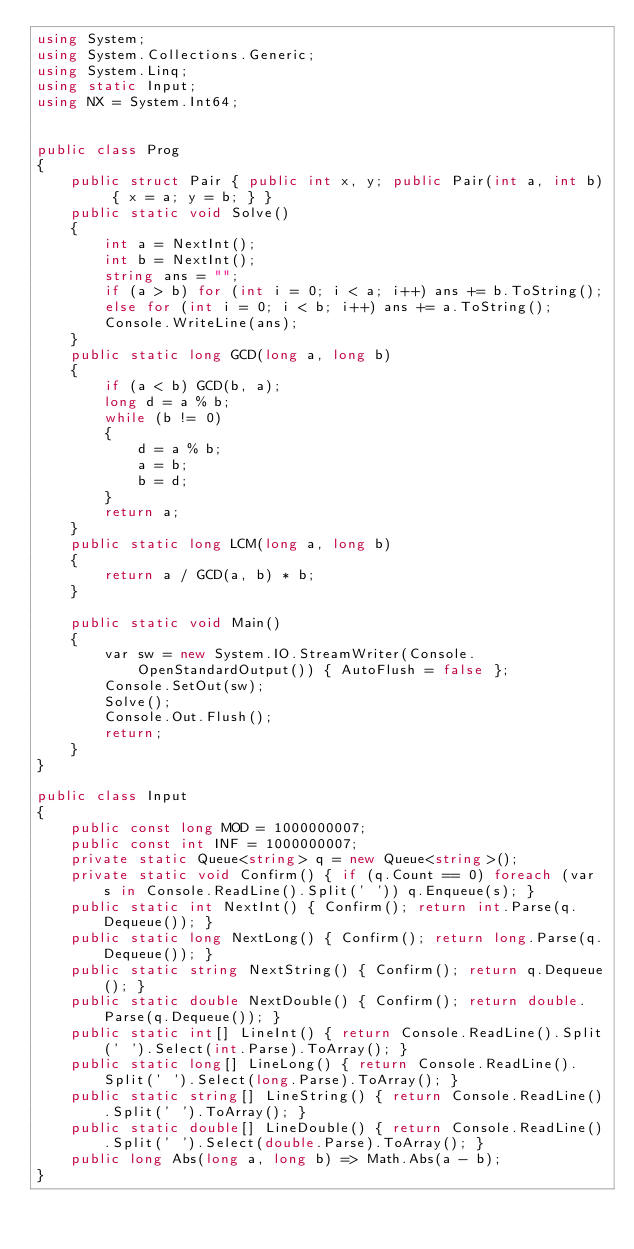Convert code to text. <code><loc_0><loc_0><loc_500><loc_500><_C#_>using System;
using System.Collections.Generic;
using System.Linq;
using static Input;
using NX = System.Int64;


public class Prog
{
    public struct Pair { public int x, y; public Pair(int a, int b) { x = a; y = b; } }
    public static void Solve()
    {
        int a = NextInt();
        int b = NextInt();
        string ans = "";
        if (a > b) for (int i = 0; i < a; i++) ans += b.ToString(); 
        else for (int i = 0; i < b; i++) ans += a.ToString();
        Console.WriteLine(ans);
    }
    public static long GCD(long a, long b)
    {
        if (a < b) GCD(b, a);
        long d = a % b;
        while (b != 0)
        {
            d = a % b;
            a = b;
            b = d;
        }
        return a;
    }
    public static long LCM(long a, long b)
    {
        return a / GCD(a, b) * b;
    }

    public static void Main()
    {
        var sw = new System.IO.StreamWriter(Console.OpenStandardOutput()) { AutoFlush = false };
        Console.SetOut(sw);
        Solve();
        Console.Out.Flush();
        return;
    }
}

public class Input
{
    public const long MOD = 1000000007;
    public const int INF = 1000000007;
    private static Queue<string> q = new Queue<string>();
    private static void Confirm() { if (q.Count == 0) foreach (var s in Console.ReadLine().Split(' ')) q.Enqueue(s); }
    public static int NextInt() { Confirm(); return int.Parse(q.Dequeue()); }
    public static long NextLong() { Confirm(); return long.Parse(q.Dequeue()); }
    public static string NextString() { Confirm(); return q.Dequeue(); }
    public static double NextDouble() { Confirm(); return double.Parse(q.Dequeue()); }
    public static int[] LineInt() { return Console.ReadLine().Split(' ').Select(int.Parse).ToArray(); }
    public static long[] LineLong() { return Console.ReadLine().Split(' ').Select(long.Parse).ToArray(); }
    public static string[] LineString() { return Console.ReadLine().Split(' ').ToArray(); }
    public static double[] LineDouble() { return Console.ReadLine().Split(' ').Select(double.Parse).ToArray(); }
    public long Abs(long a, long b) => Math.Abs(a - b);
}
</code> 